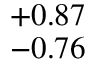<formula> <loc_0><loc_0><loc_500><loc_500>^ { + 0 . 8 7 } _ { - 0 . 7 6 }</formula> 